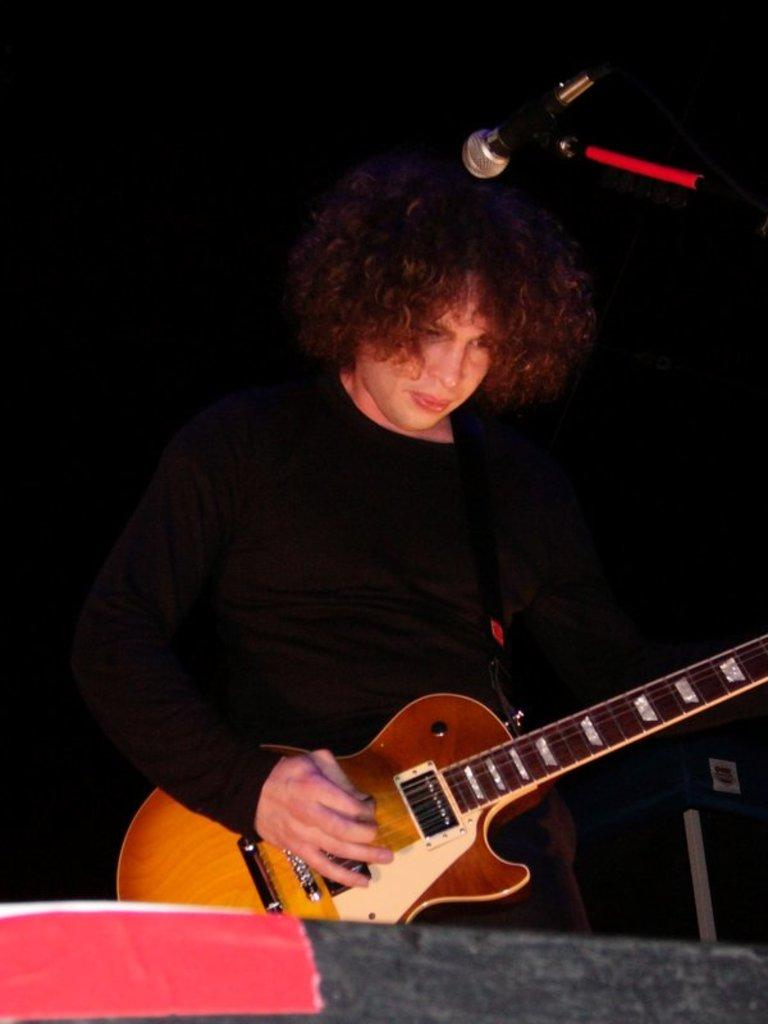Who is the main subject in the image? There is a woman in the image. What is the woman holding in the image? The woman is holding a guitar. What is the woman standing in front of in the image? The woman is in front of a microphone. What color is the dress the woman is wearing? The woman is wearing a black dress. How does the woman in the image provide care for her neck? There is no information about the woman providing care for her neck in the image. 